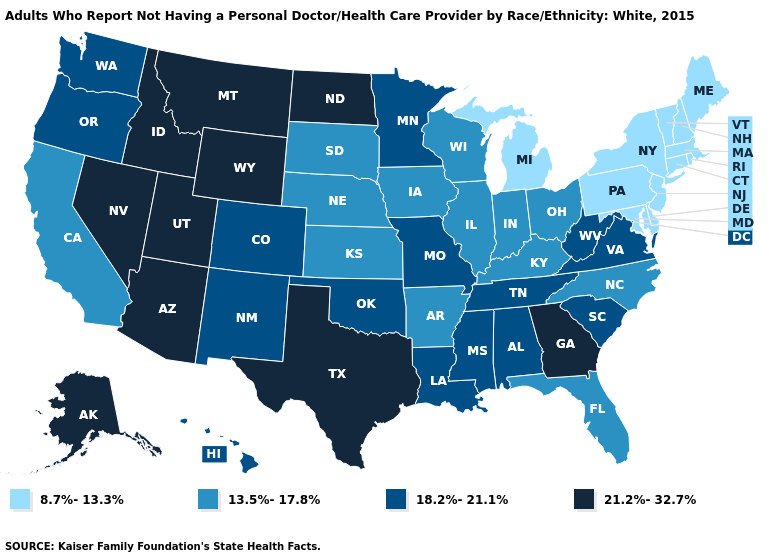What is the lowest value in states that border Wisconsin?
Write a very short answer. 8.7%-13.3%. What is the highest value in the MidWest ?
Give a very brief answer. 21.2%-32.7%. How many symbols are there in the legend?
Keep it brief. 4. Does North Carolina have the lowest value in the USA?
Be succinct. No. What is the highest value in the West ?
Give a very brief answer. 21.2%-32.7%. Which states have the lowest value in the USA?
Concise answer only. Connecticut, Delaware, Maine, Maryland, Massachusetts, Michigan, New Hampshire, New Jersey, New York, Pennsylvania, Rhode Island, Vermont. Among the states that border California , does Oregon have the highest value?
Answer briefly. No. What is the value of South Dakota?
Concise answer only. 13.5%-17.8%. Name the states that have a value in the range 18.2%-21.1%?
Short answer required. Alabama, Colorado, Hawaii, Louisiana, Minnesota, Mississippi, Missouri, New Mexico, Oklahoma, Oregon, South Carolina, Tennessee, Virginia, Washington, West Virginia. Which states hav the highest value in the West?
Concise answer only. Alaska, Arizona, Idaho, Montana, Nevada, Utah, Wyoming. Does the first symbol in the legend represent the smallest category?
Answer briefly. Yes. What is the value of New Jersey?
Quick response, please. 8.7%-13.3%. Name the states that have a value in the range 8.7%-13.3%?
Concise answer only. Connecticut, Delaware, Maine, Maryland, Massachusetts, Michigan, New Hampshire, New Jersey, New York, Pennsylvania, Rhode Island, Vermont. Name the states that have a value in the range 13.5%-17.8%?
Write a very short answer. Arkansas, California, Florida, Illinois, Indiana, Iowa, Kansas, Kentucky, Nebraska, North Carolina, Ohio, South Dakota, Wisconsin. What is the highest value in the USA?
Keep it brief. 21.2%-32.7%. 